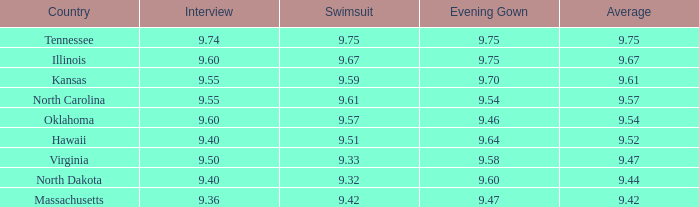What was the interview score for Hawaii? 9.4. 